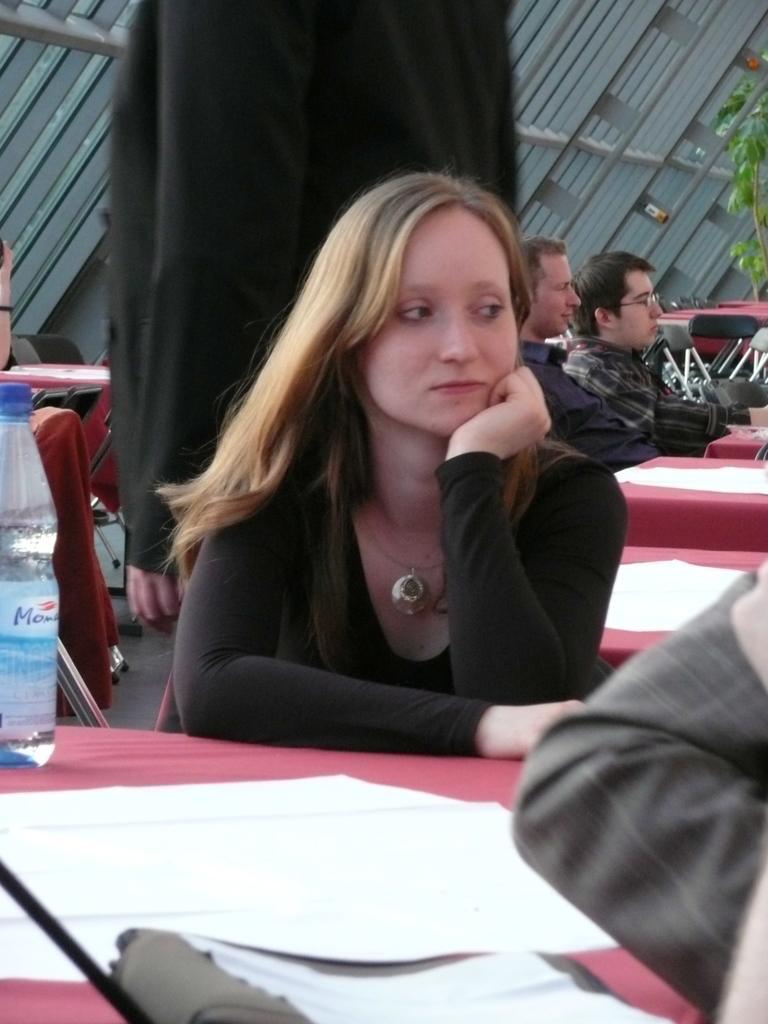Describe this image in one or two sentences. In this image there are tables, chairs and papers. There is bottle on the left side. There is a tree on the right side. There are people sitting. There is a gray color background. 